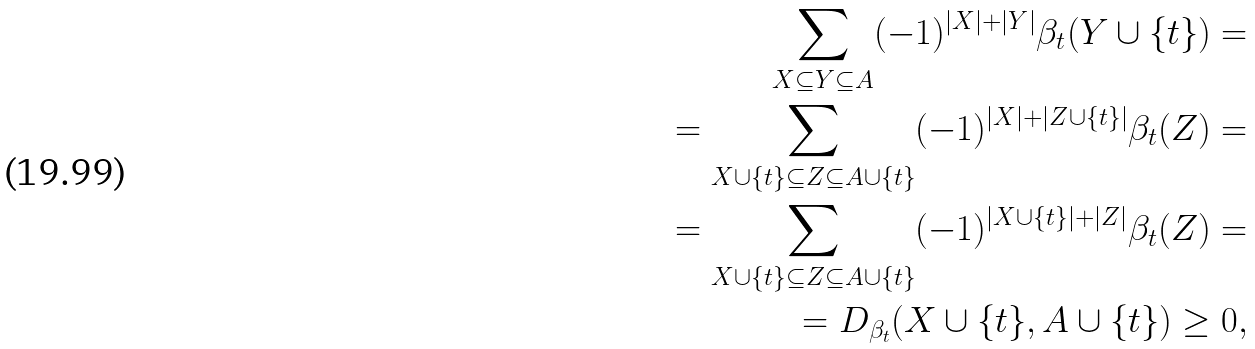<formula> <loc_0><loc_0><loc_500><loc_500>\sum _ { X \subseteq Y \subseteq A } ( - 1 ) ^ { | X | + | Y | } { \beta _ { t } } ( Y \cup \{ t \} ) = \\ = \sum _ { X \cup \{ t \} \subseteq Z \subseteq A \cup \{ t \} } ( - 1 ) ^ { | X | + | Z \cup \{ t \} | } { \beta _ { t } } ( Z ) = \\ = \sum _ { X \cup \{ t \} \subseteq Z \subseteq A \cup \{ t \} } ( - 1 ) ^ { | X \cup \{ t \} | + | Z | } { \beta _ { t } } ( Z ) = \\ = D _ { \beta _ { t } } ( X \cup \{ t \} , A \cup \{ t \} ) \geq 0 ,</formula> 